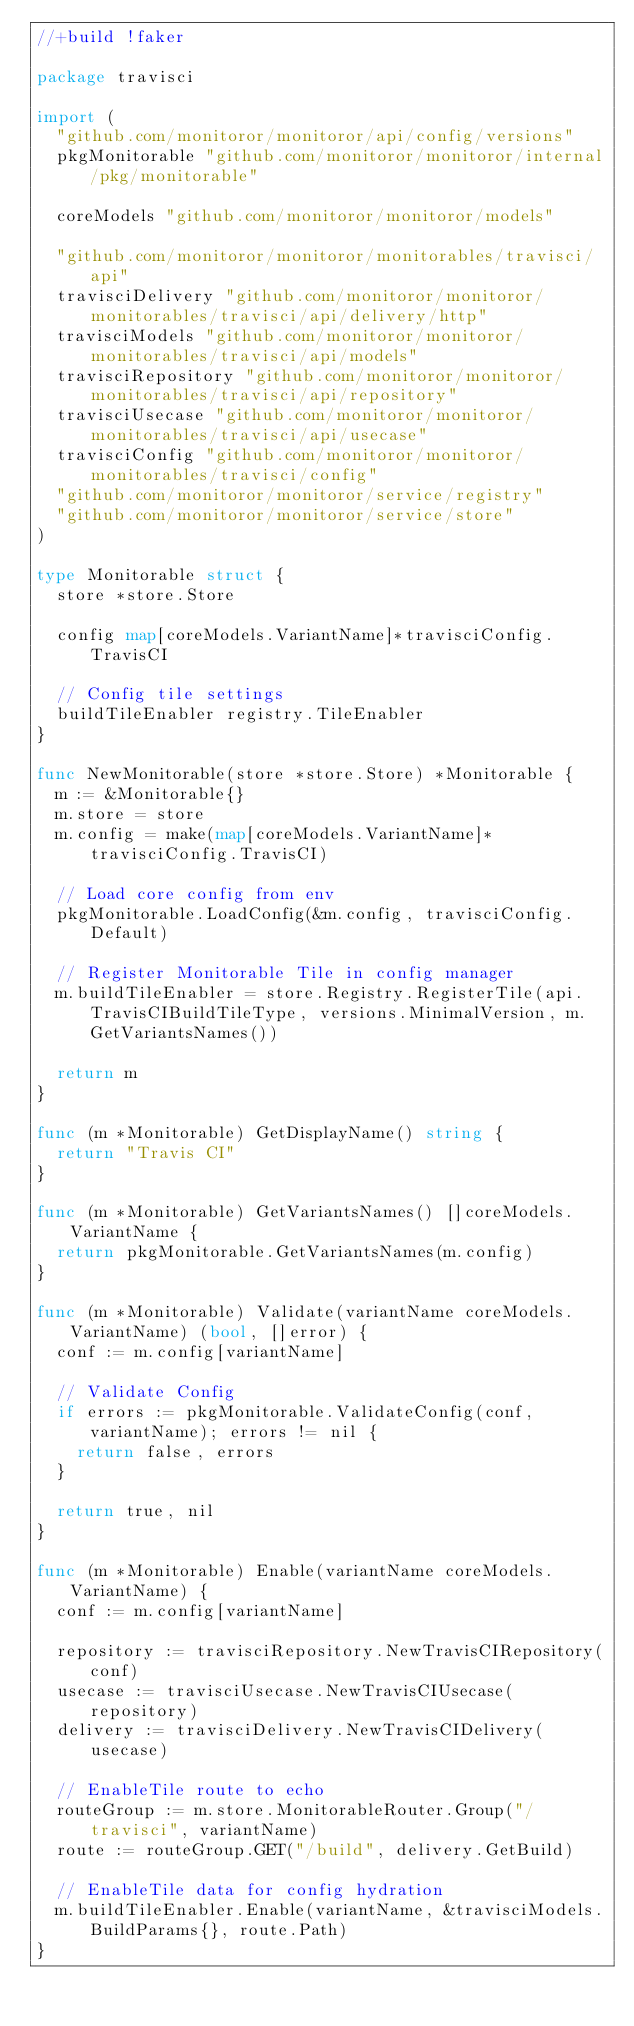Convert code to text. <code><loc_0><loc_0><loc_500><loc_500><_Go_>//+build !faker

package travisci

import (
	"github.com/monitoror/monitoror/api/config/versions"
	pkgMonitorable "github.com/monitoror/monitoror/internal/pkg/monitorable"

	coreModels "github.com/monitoror/monitoror/models"

	"github.com/monitoror/monitoror/monitorables/travisci/api"
	travisciDelivery "github.com/monitoror/monitoror/monitorables/travisci/api/delivery/http"
	travisciModels "github.com/monitoror/monitoror/monitorables/travisci/api/models"
	travisciRepository "github.com/monitoror/monitoror/monitorables/travisci/api/repository"
	travisciUsecase "github.com/monitoror/monitoror/monitorables/travisci/api/usecase"
	travisciConfig "github.com/monitoror/monitoror/monitorables/travisci/config"
	"github.com/monitoror/monitoror/service/registry"
	"github.com/monitoror/monitoror/service/store"
)

type Monitorable struct {
	store *store.Store

	config map[coreModels.VariantName]*travisciConfig.TravisCI

	// Config tile settings
	buildTileEnabler registry.TileEnabler
}

func NewMonitorable(store *store.Store) *Monitorable {
	m := &Monitorable{}
	m.store = store
	m.config = make(map[coreModels.VariantName]*travisciConfig.TravisCI)

	// Load core config from env
	pkgMonitorable.LoadConfig(&m.config, travisciConfig.Default)

	// Register Monitorable Tile in config manager
	m.buildTileEnabler = store.Registry.RegisterTile(api.TravisCIBuildTileType, versions.MinimalVersion, m.GetVariantsNames())

	return m
}

func (m *Monitorable) GetDisplayName() string {
	return "Travis CI"
}

func (m *Monitorable) GetVariantsNames() []coreModels.VariantName {
	return pkgMonitorable.GetVariantsNames(m.config)
}

func (m *Monitorable) Validate(variantName coreModels.VariantName) (bool, []error) {
	conf := m.config[variantName]

	// Validate Config
	if errors := pkgMonitorable.ValidateConfig(conf, variantName); errors != nil {
		return false, errors
	}

	return true, nil
}

func (m *Monitorable) Enable(variantName coreModels.VariantName) {
	conf := m.config[variantName]

	repository := travisciRepository.NewTravisCIRepository(conf)
	usecase := travisciUsecase.NewTravisCIUsecase(repository)
	delivery := travisciDelivery.NewTravisCIDelivery(usecase)

	// EnableTile route to echo
	routeGroup := m.store.MonitorableRouter.Group("/travisci", variantName)
	route := routeGroup.GET("/build", delivery.GetBuild)

	// EnableTile data for config hydration
	m.buildTileEnabler.Enable(variantName, &travisciModels.BuildParams{}, route.Path)
}
</code> 